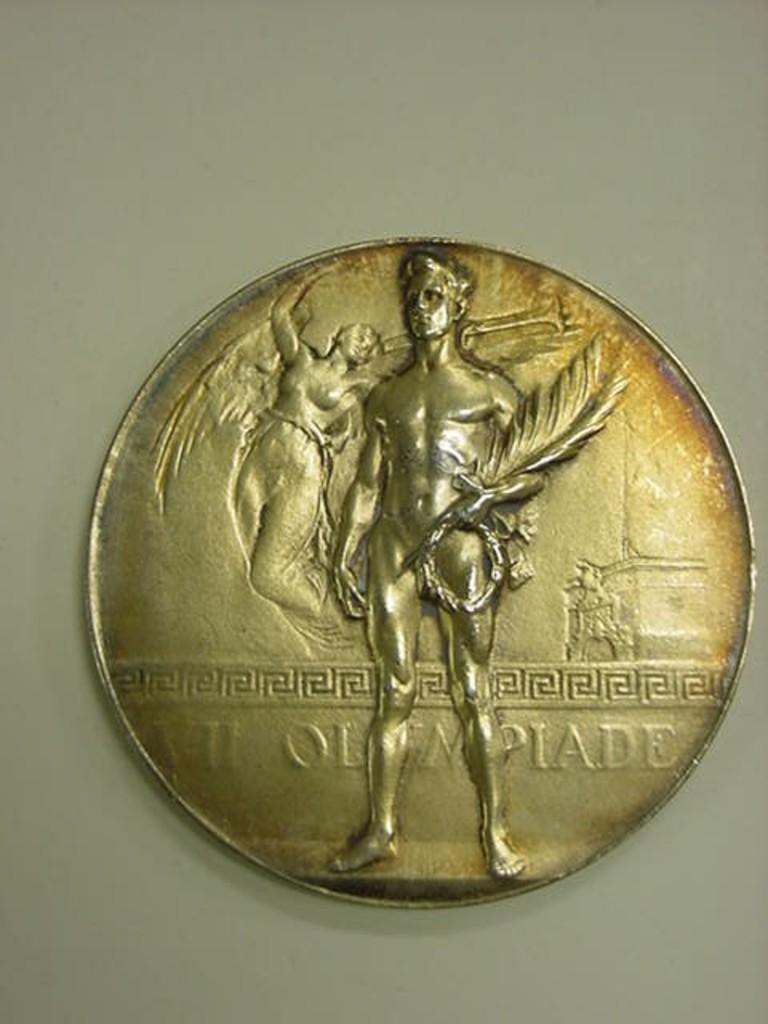What word appears on the coin?
Ensure brevity in your answer.  Olympiade. 